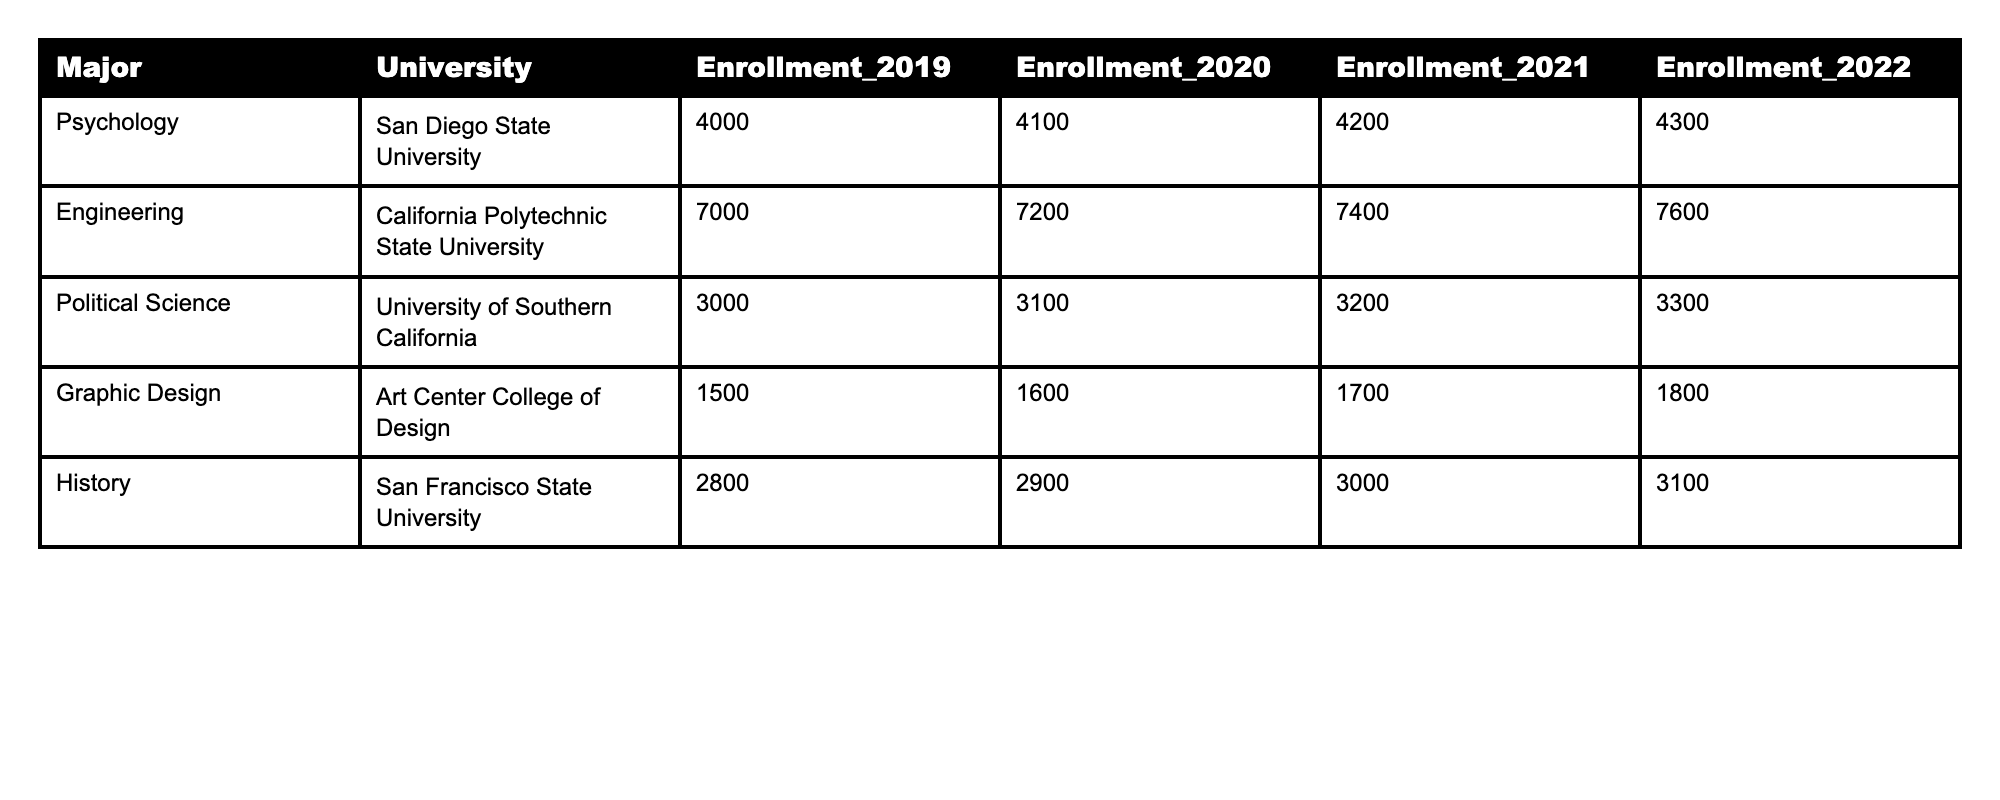What was the enrollment for Psychology at San Diego State University in 2021? The table shows the enrollment for Psychology at San Diego State University for 2021 as 4200.
Answer: 4200 Which major had the highest enrollment in 2022? By comparing the enrollment numbers for all majors in 2022, Engineering at California Polytechnic State University has the highest enrollment of 7600.
Answer: Engineering What was the total enrollment for Political Science and History in 2022? The enrollment for Political Science in 2022 was 3300, and for History, it was 3100. Adding these together gives 3300 + 3100 = 6400.
Answer: 6400 Did the enrollment for Graphic Design increase every year from 2019 to 2022? The enrollment for Graphic Design increased each year: 1500 in 2019, 1600 in 2020, 1700 in 2021, and 1800 in 2022. Therefore, the statement is true.
Answer: Yes What is the average enrollment for all majors in 2020? The enrollments for 2020 are 4100 (Psychology), 7200 (Engineering), 3100 (Political Science), 1600 (Graphic Design), and 2900 (History). The total is 4100 + 7200 + 3100 + 1600 + 2900 = 18800. The average is 18800 / 5 = 3760.
Answer: 3760 Which major had the smallest enrollment in 2019? The table shows that Graphic Design had the smallest enrollment in 2019, which was 1500.
Answer: Graphic Design How much did enrollment for Engineering grow from 2019 to 2022? The enrollment for Engineering in 2019 was 7000 and in 2022 was 7600. The increase is 7600 - 7000 = 600.
Answer: 600 What is the total enrollment across all majors in 2021? The total enrollments for 2021 are 4200 (Psychology), 7400 (Engineering), 3200 (Political Science), 1700 (Graphic Design), and 3000 (History). Adding these gives 4200 + 7400 + 3200 + 1700 + 3000 = 19600.
Answer: 19600 Was there an increase in enrollment for all majors from 2019 to 2022? Analyzing the enrollment numbers, all majors show an increase from 2019 to 2022, confirming that the statement is true.
Answer: Yes What is the difference in enrollment between the highest and lowest major in 2022? The highest enrollment in 2022 was Engineering with 7600, and the lowest was Graphic Design with 1800. The difference is 7600 - 1800 = 5800.
Answer: 5800 How many students were enrolled in Political Science in 2020? The enrollment for Political Science in 2020 was 3100 as indicated in the table.
Answer: 3100 